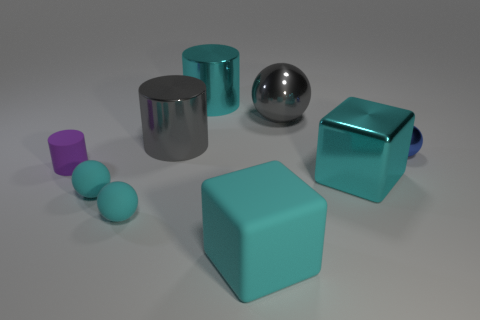Subtract all large shiny balls. How many balls are left? 3 Subtract all cyan cylinders. How many cylinders are left? 2 Add 8 big cyan cylinders. How many big cyan cylinders exist? 9 Subtract 0 yellow blocks. How many objects are left? 9 Subtract all cylinders. How many objects are left? 6 Subtract 2 cylinders. How many cylinders are left? 1 Subtract all yellow cylinders. Subtract all cyan cubes. How many cylinders are left? 3 Subtract all gray balls. How many green blocks are left? 0 Subtract all large metallic cylinders. Subtract all cyan rubber objects. How many objects are left? 4 Add 2 purple cylinders. How many purple cylinders are left? 3 